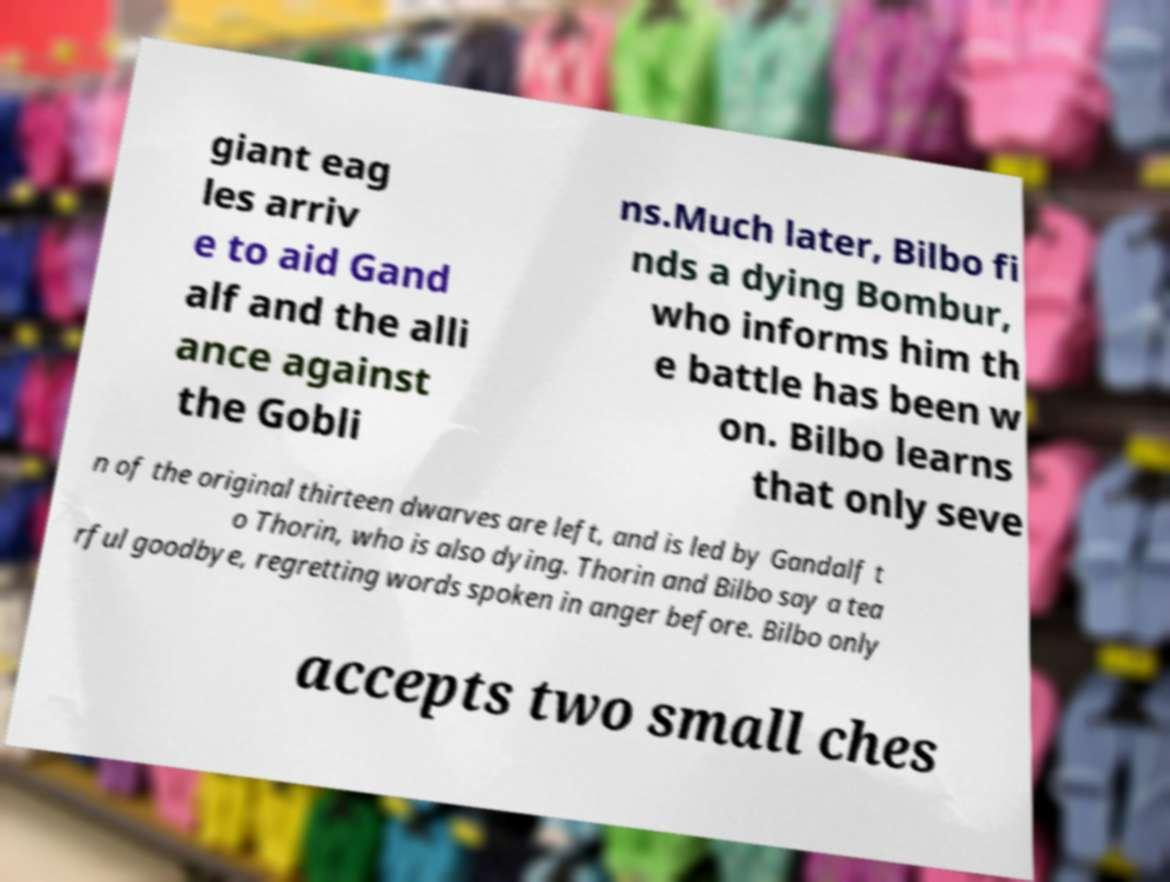Can you accurately transcribe the text from the provided image for me? giant eag les arriv e to aid Gand alf and the alli ance against the Gobli ns.Much later, Bilbo fi nds a dying Bombur, who informs him th e battle has been w on. Bilbo learns that only seve n of the original thirteen dwarves are left, and is led by Gandalf t o Thorin, who is also dying. Thorin and Bilbo say a tea rful goodbye, regretting words spoken in anger before. Bilbo only accepts two small ches 